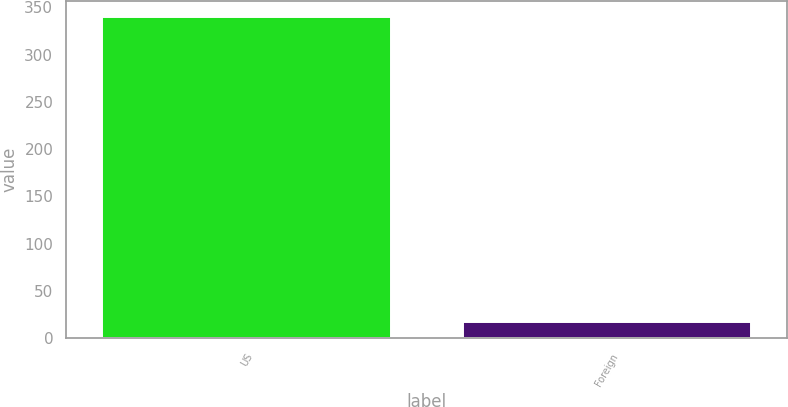<chart> <loc_0><loc_0><loc_500><loc_500><bar_chart><fcel>US<fcel>Foreign<nl><fcel>339.6<fcel>16.7<nl></chart> 